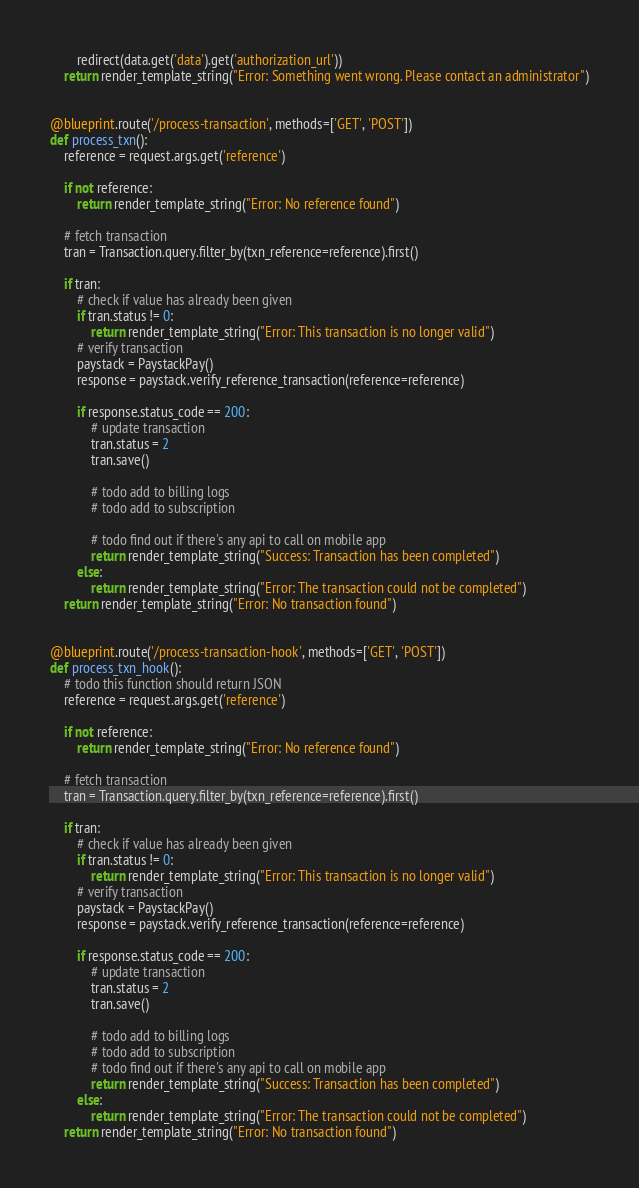Convert code to text. <code><loc_0><loc_0><loc_500><loc_500><_Python_>        redirect(data.get('data').get('authorization_url'))
    return render_template_string("Error: Something went wrong. Please contact an administrator")


@blueprint.route('/process-transaction', methods=['GET', 'POST'])
def process_txn():
    reference = request.args.get('reference')

    if not reference:
        return render_template_string("Error: No reference found")

    # fetch transaction
    tran = Transaction.query.filter_by(txn_reference=reference).first()

    if tran:
        # check if value has already been given
        if tran.status != 0:
            return render_template_string("Error: This transaction is no longer valid")
        # verify transaction
        paystack = PaystackPay()
        response = paystack.verify_reference_transaction(reference=reference)

        if response.status_code == 200:
            # update transaction
            tran.status = 2
            tran.save()

            # todo add to billing logs
            # todo add to subscription

            # todo find out if there's any api to call on mobile app
            return render_template_string("Success: Transaction has been completed")
        else:
            return render_template_string("Error: The transaction could not be completed")
    return render_template_string("Error: No transaction found")


@blueprint.route('/process-transaction-hook', methods=['GET', 'POST'])
def process_txn_hook():
    # todo this function should return JSON
    reference = request.args.get('reference')

    if not reference:
        return render_template_string("Error: No reference found")

    # fetch transaction
    tran = Transaction.query.filter_by(txn_reference=reference).first()

    if tran:
        # check if value has already been given
        if tran.status != 0:
            return render_template_string("Error: This transaction is no longer valid")
        # verify transaction
        paystack = PaystackPay()
        response = paystack.verify_reference_transaction(reference=reference)

        if response.status_code == 200:
            # update transaction
            tran.status = 2
            tran.save()

            # todo add to billing logs
            # todo add to subscription
            # todo find out if there's any api to call on mobile app
            return render_template_string("Success: Transaction has been completed")
        else:
            return render_template_string("Error: The transaction could not be completed")
    return render_template_string("Error: No transaction found")</code> 